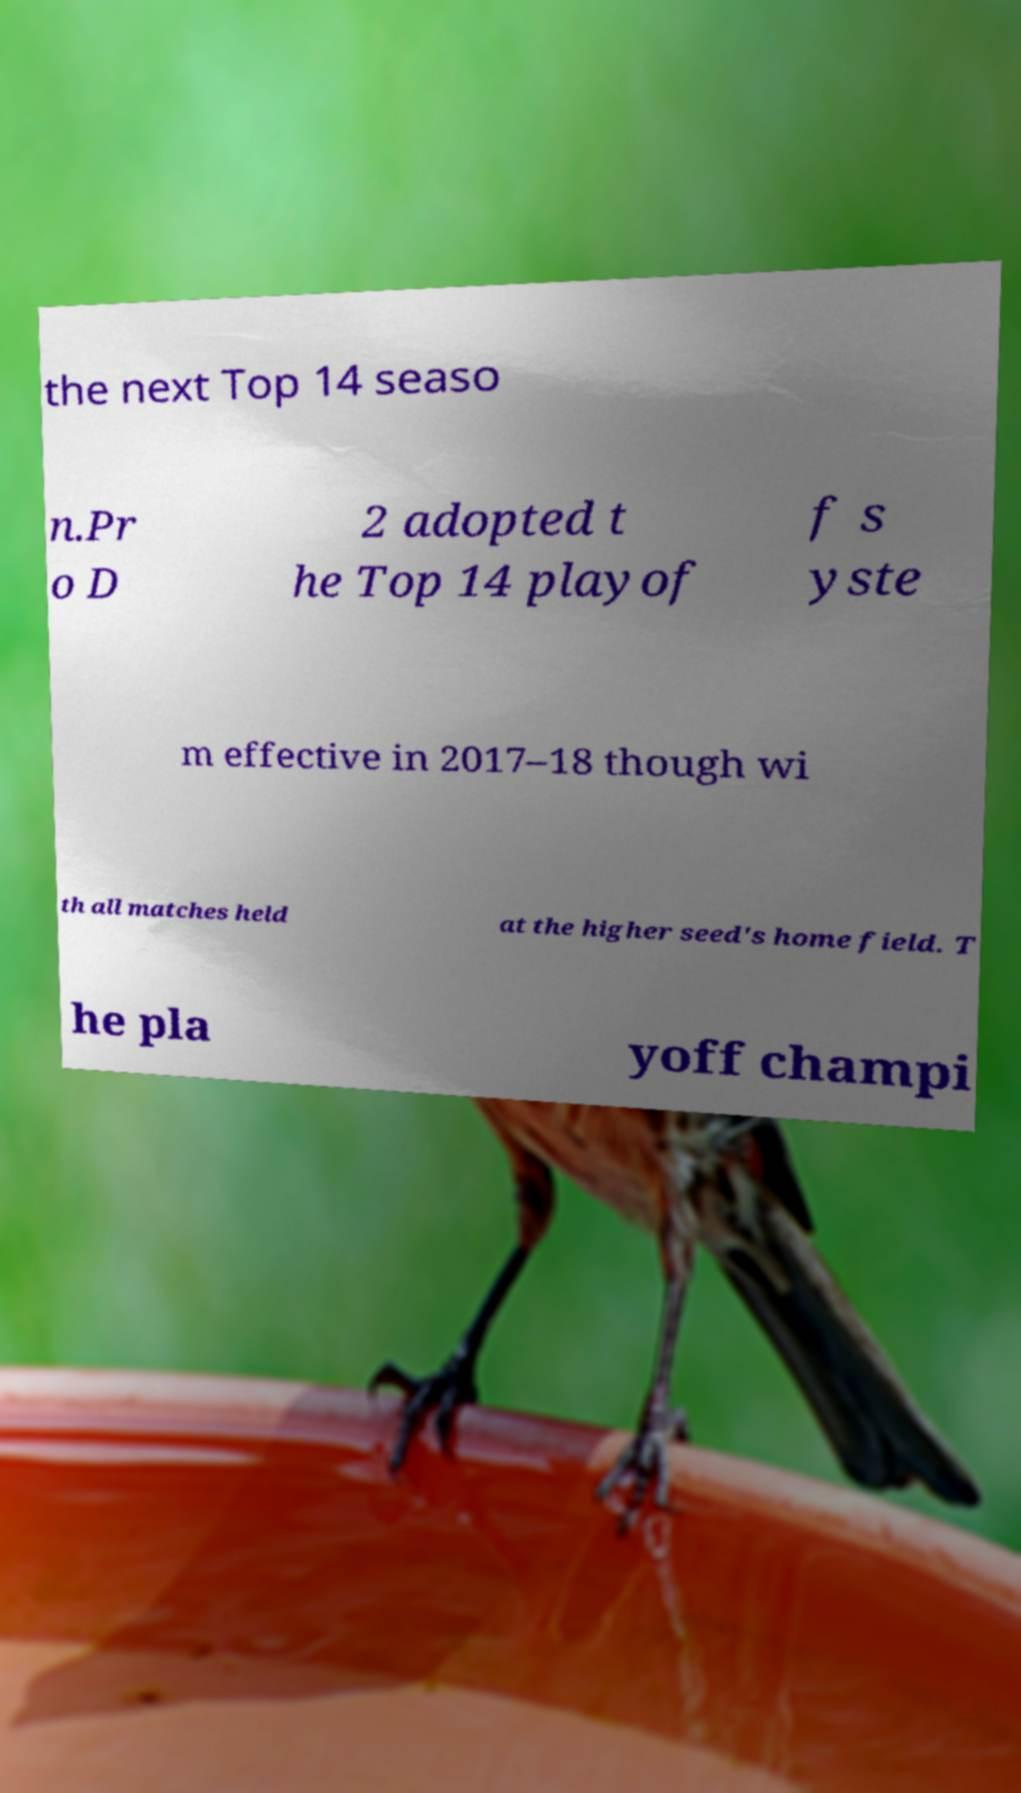Can you read and provide the text displayed in the image?This photo seems to have some interesting text. Can you extract and type it out for me? the next Top 14 seaso n.Pr o D 2 adopted t he Top 14 playof f s yste m effective in 2017–18 though wi th all matches held at the higher seed's home field. T he pla yoff champi 